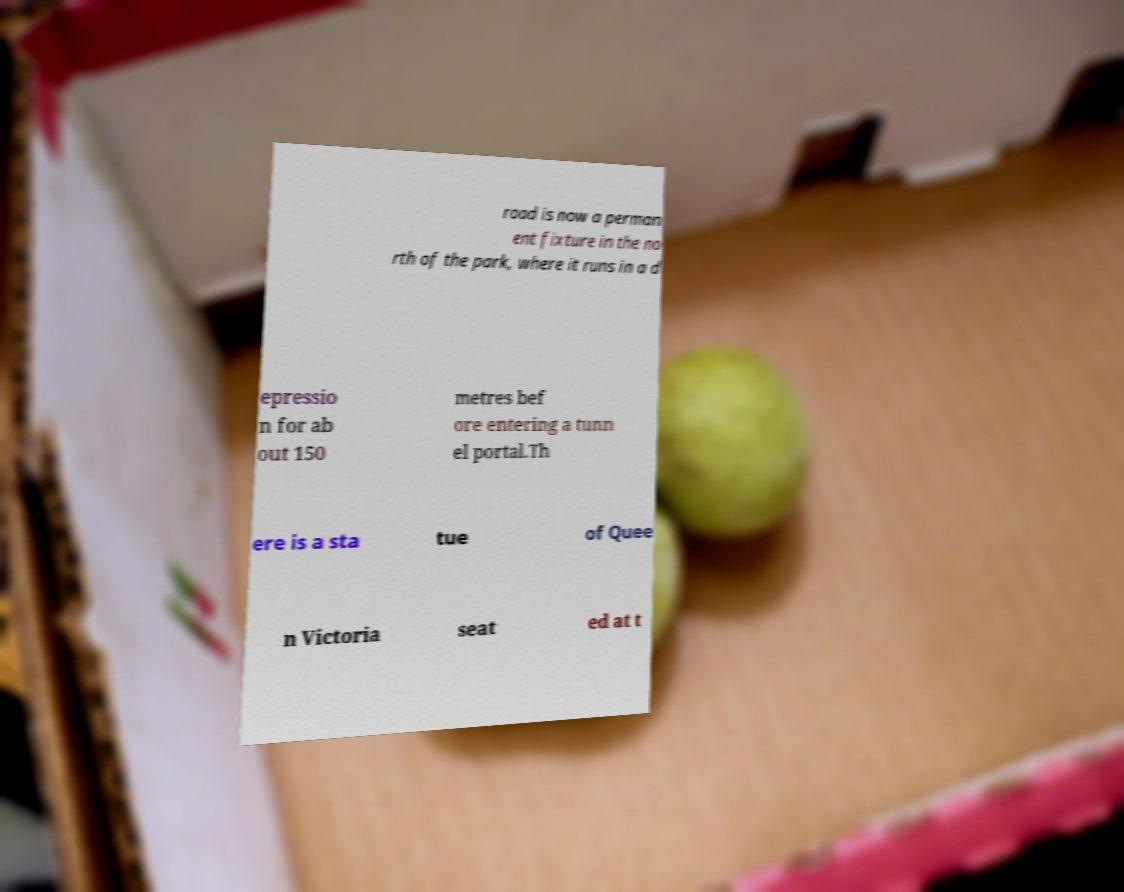What messages or text are displayed in this image? I need them in a readable, typed format. road is now a perman ent fixture in the no rth of the park, where it runs in a d epressio n for ab out 150 metres bef ore entering a tunn el portal.Th ere is a sta tue of Quee n Victoria seat ed at t 